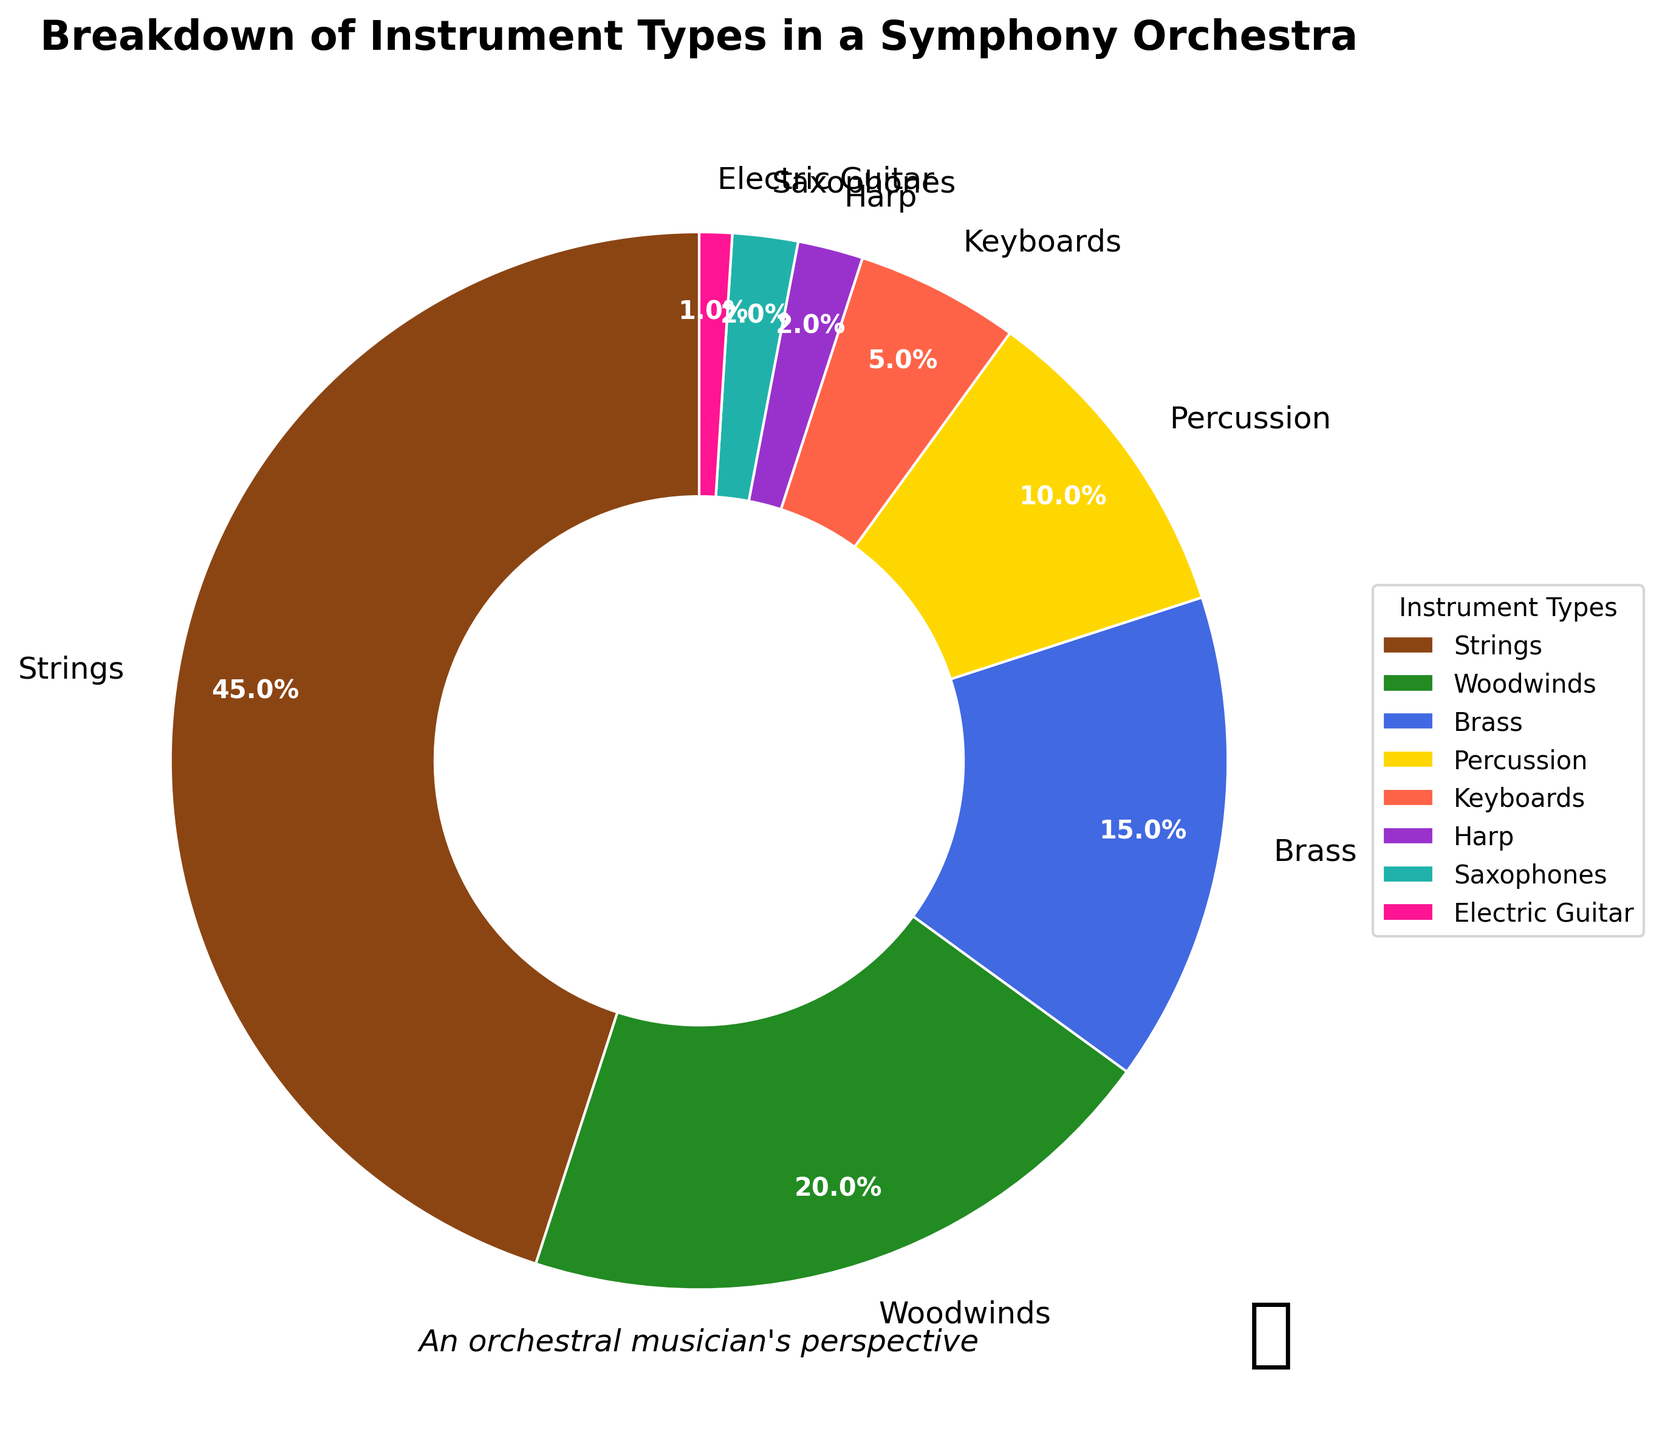What's the percentage of strings and percussion combined? To find the combined percentage of strings and percussion, add their respective percentages: 45% (strings) + 10% (percussion) = 55%.
Answer: 55% Which instrument type has the smallest representation in the pie chart? Observe the pie chart and check the percentages. The electric guitar has the smallest representation at 1%.
Answer: Electric Guitar What is the ratio of woodwinds to brass instruments? Determine the percentages for woodwinds (20%) and brass (15%). The ratio is 20 to 15, which simplifies to 4 to 3.
Answer: 4:3 What is the difference in percentage between strings and woodwinds? Subtract the percentage of woodwinds (20%) from the percentage of strings (45%): 45% - 20% = 25%.
Answer: 25% If you combine brass and percussion, is their percentage more than the woodwinds? Find the sum of brass (15%) and percussion (10%): 15% + 10% = 25%. Compare it with woodwinds (20%). Since 25% > 20%, the combined percentage is more.
Answer: Yes Which instrument type is represented by purple in the pie chart? Identify the color purple in the pie chart and match it with the instrument type. The harp is represented by purple.
Answer: Harp Are the percentages of saxophones and electric guitar equal? Check the percentages of saxophones (2%) and electric guitar (1%). Since 2% ≠ 1%, they are not equal.
Answer: No What's the total percentage of all non-strings instrument types? Sum the percentages of woodwinds (20%), brass (15%), percussion (10%), keyboards (5%), harp (2%), saxophones (2%), and electric guitar (1%): 20% + 15% + 10% + 5% + 2% + 2% + 1% = 55%.
Answer: 55% Which instrument type takes up the largest portion of the pie chart, and what's its percentage? Look at the pie chart and find the instrument type with the largest wedge. Strings have the largest portion at 45%.
Answer: Strings, 45% Is the sum of percentages for brass, percussion, and keyboards greater than the sum for harp, saxophones, and electric guitar? Calculate the sum for brass (15%), percussion (10%), and keyboards (5%): 15% + 10% + 5% = 30%. Calculate the sum for harp (2%), saxophones (2%), and electric guitar (1%): 2% + 2% + 1% = 5%. Since 30% > 5%, the sum is greater.
Answer: Yes 